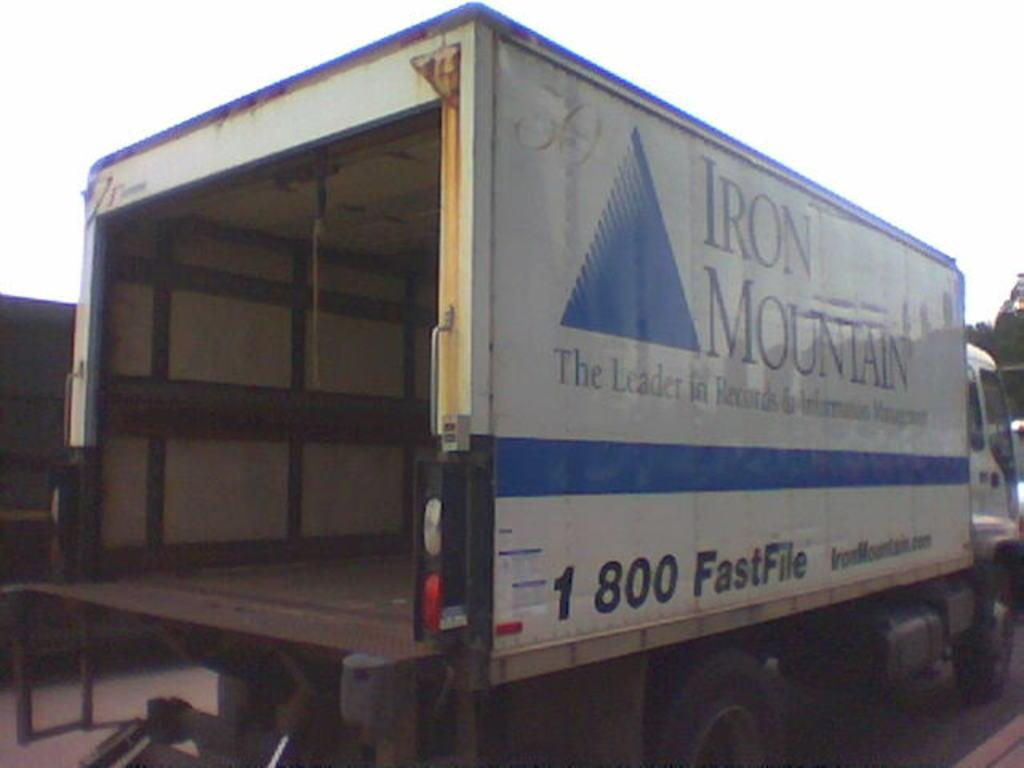What can be seen on the road in the image? There are vehicles on the road in the image. How many springs are visible on the vehicles in the image? There is no mention of springs in the image, as it only states that there are vehicles on the road. 